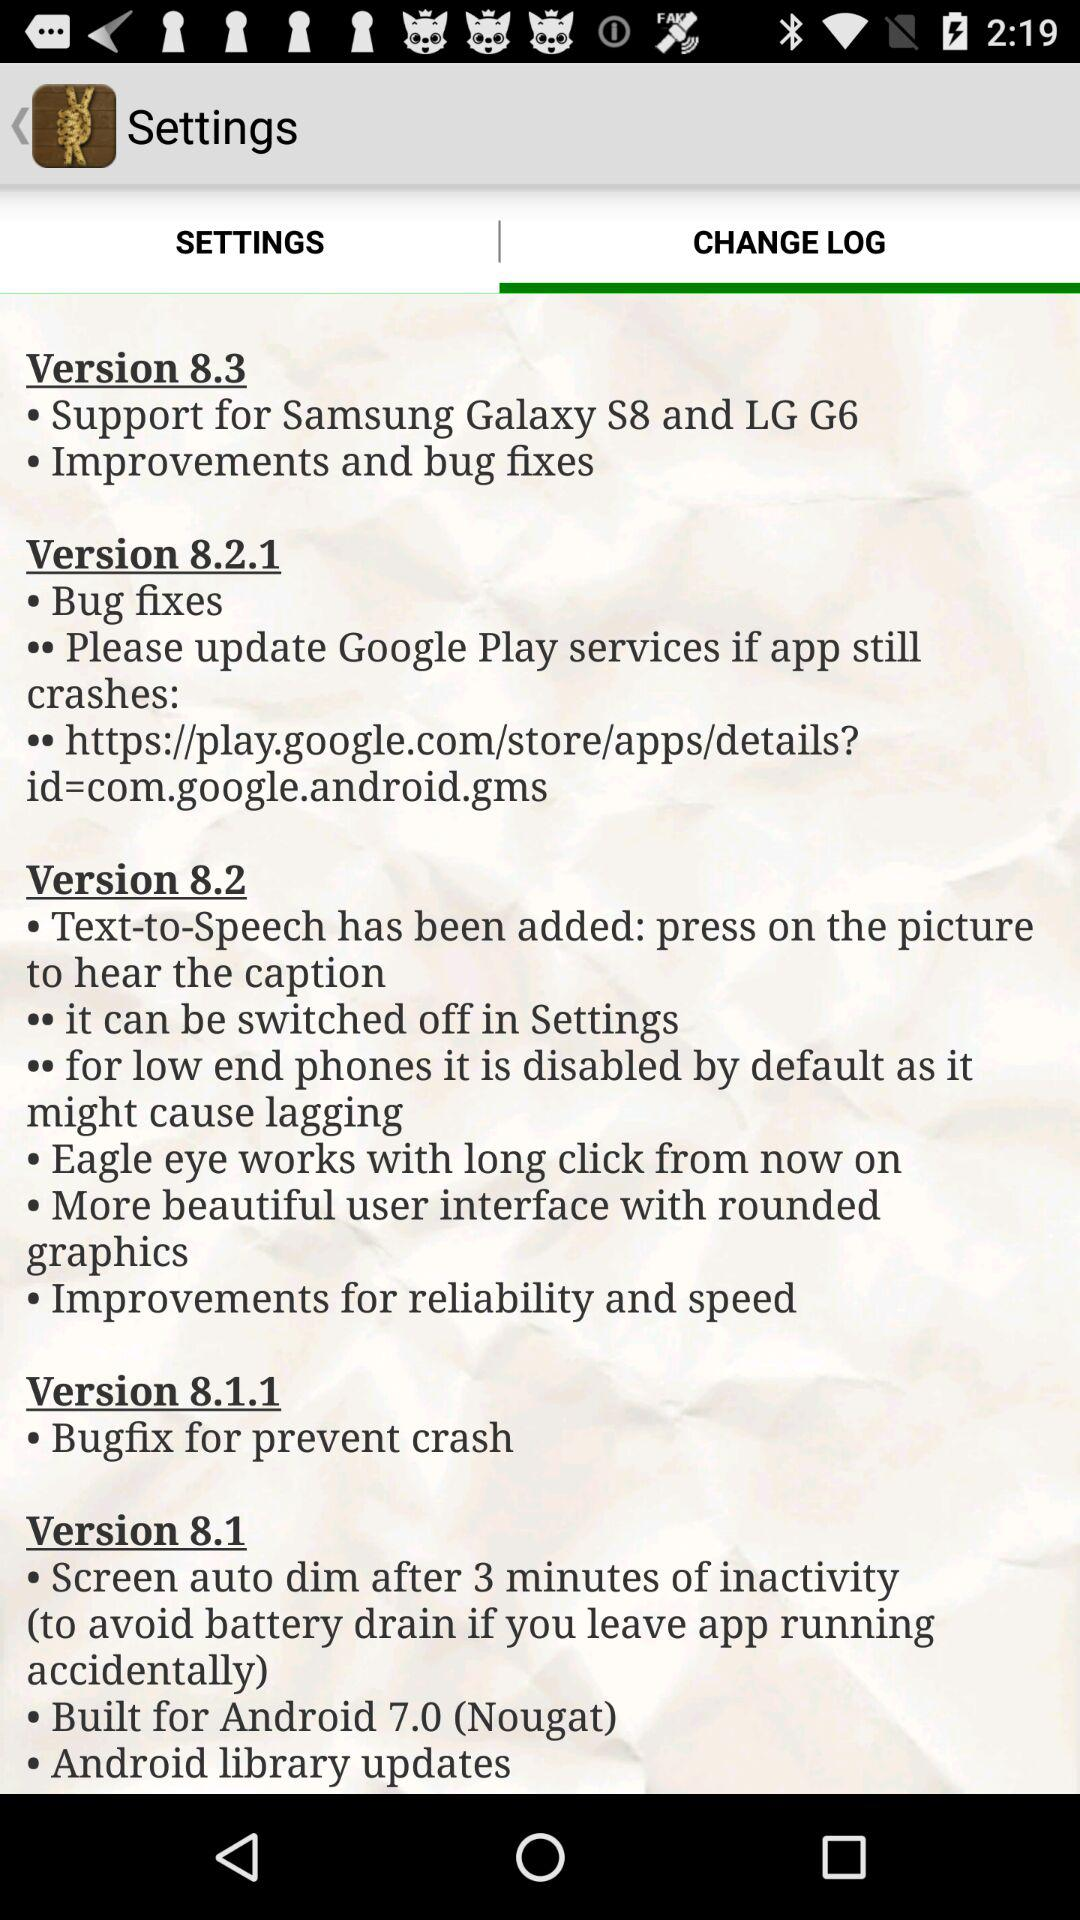In which version does the screen auto-dim after 3 minutes of inactivity? The screen auto-dim after 3 minutes of inactivity in version 8.1. 